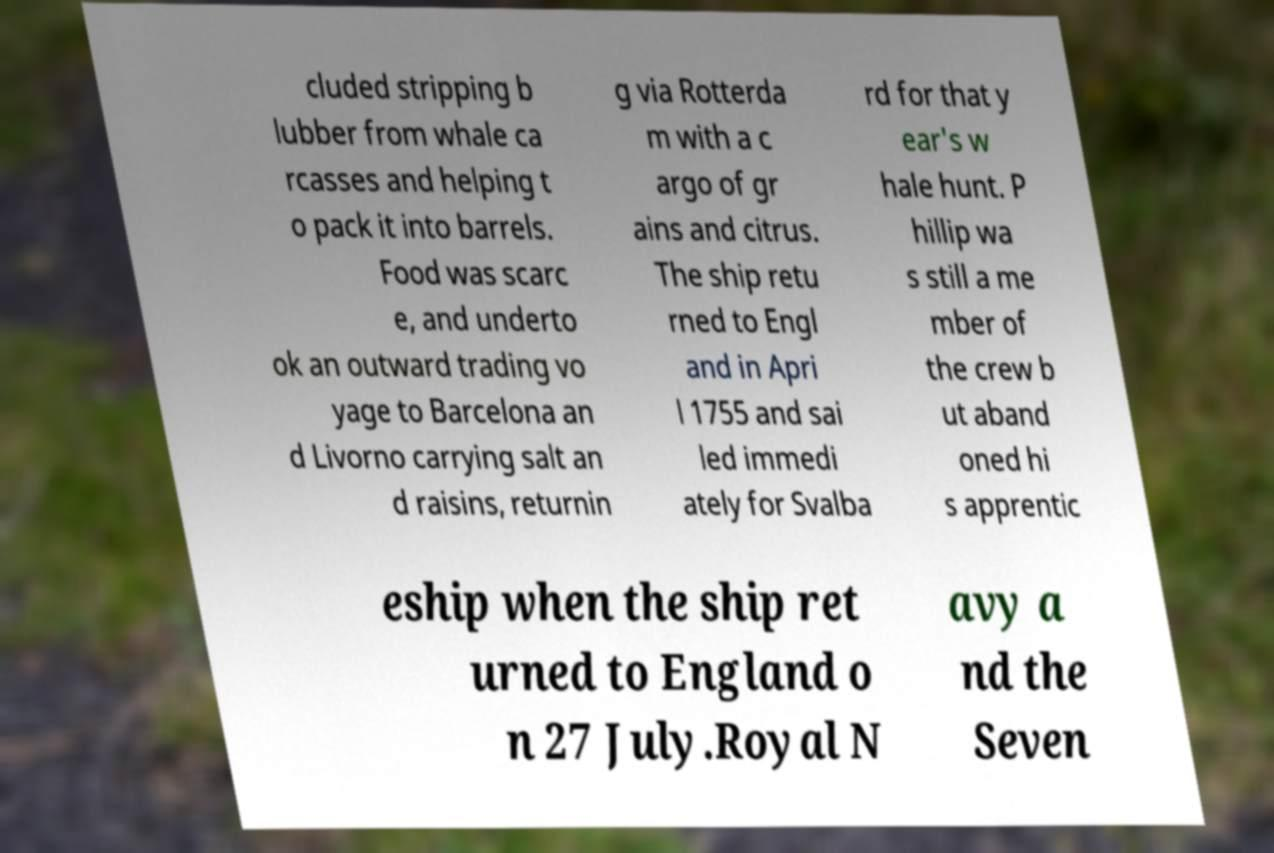There's text embedded in this image that I need extracted. Can you transcribe it verbatim? cluded stripping b lubber from whale ca rcasses and helping t o pack it into barrels. Food was scarc e, and underto ok an outward trading vo yage to Barcelona an d Livorno carrying salt an d raisins, returnin g via Rotterda m with a c argo of gr ains and citrus. The ship retu rned to Engl and in Apri l 1755 and sai led immedi ately for Svalba rd for that y ear's w hale hunt. P hillip wa s still a me mber of the crew b ut aband oned hi s apprentic eship when the ship ret urned to England o n 27 July.Royal N avy a nd the Seven 